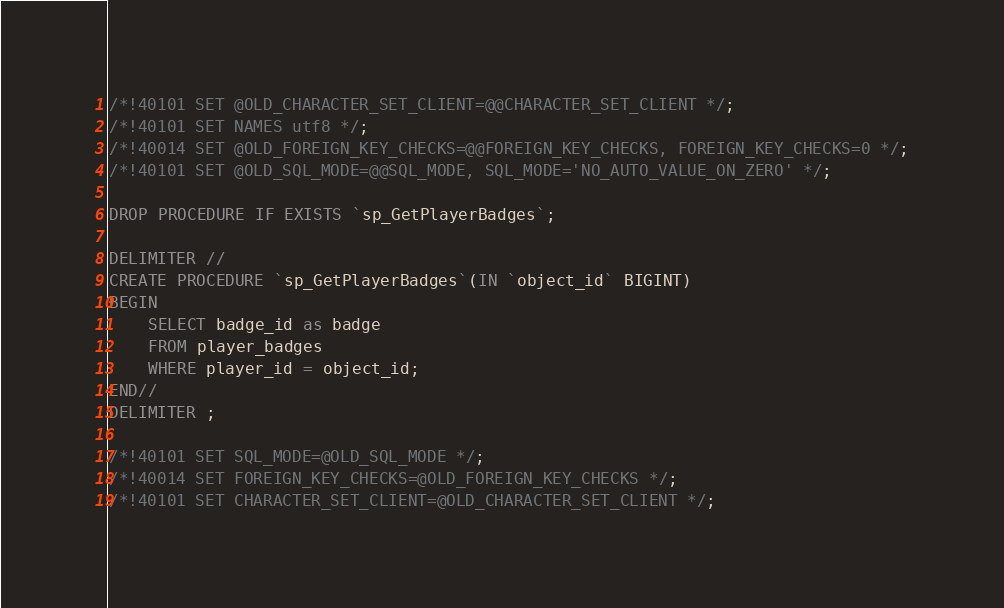Convert code to text. <code><loc_0><loc_0><loc_500><loc_500><_SQL_>
/*!40101 SET @OLD_CHARACTER_SET_CLIENT=@@CHARACTER_SET_CLIENT */;
/*!40101 SET NAMES utf8 */;
/*!40014 SET @OLD_FOREIGN_KEY_CHECKS=@@FOREIGN_KEY_CHECKS, FOREIGN_KEY_CHECKS=0 */;
/*!40101 SET @OLD_SQL_MODE=@@SQL_MODE, SQL_MODE='NO_AUTO_VALUE_ON_ZERO' */;

DROP PROCEDURE IF EXISTS `sp_GetPlayerBadges`;

DELIMITER //
CREATE PROCEDURE `sp_GetPlayerBadges`(IN `object_id` BIGINT)
BEGIN
    SELECT badge_id as badge
    FROM player_badges
    WHERE player_id = object_id;
END//
DELIMITER ;

/*!40101 SET SQL_MODE=@OLD_SQL_MODE */;
/*!40014 SET FOREIGN_KEY_CHECKS=@OLD_FOREIGN_KEY_CHECKS */;
/*!40101 SET CHARACTER_SET_CLIENT=@OLD_CHARACTER_SET_CLIENT */;
</code> 